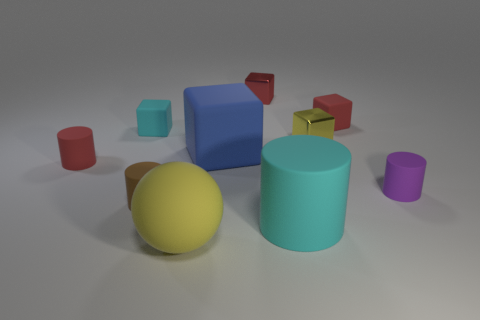The cylinder that is behind the tiny brown matte cylinder and right of the large blue rubber thing is what color?
Provide a succinct answer. Purple. What is the material of the other red block that is the same size as the red metal cube?
Provide a succinct answer. Rubber. How many other things are there of the same material as the large cyan cylinder?
Offer a very short reply. 7. Is the color of the big matte object behind the red cylinder the same as the small matte block left of the red metallic thing?
Ensure brevity in your answer.  No. The small red matte object that is to the right of the red matte thing that is left of the brown matte thing is what shape?
Your response must be concise. Cube. How many other objects are there of the same color as the big rubber ball?
Ensure brevity in your answer.  1. Do the red object that is on the left side of the big yellow object and the tiny cylinder that is right of the big block have the same material?
Offer a terse response. Yes. What is the size of the cyan matte thing on the right side of the small brown cylinder?
Provide a short and direct response. Large. There is a large object that is the same shape as the small cyan thing; what is it made of?
Provide a short and direct response. Rubber. Are there any other things that have the same size as the yellow metal object?
Your response must be concise. Yes. 